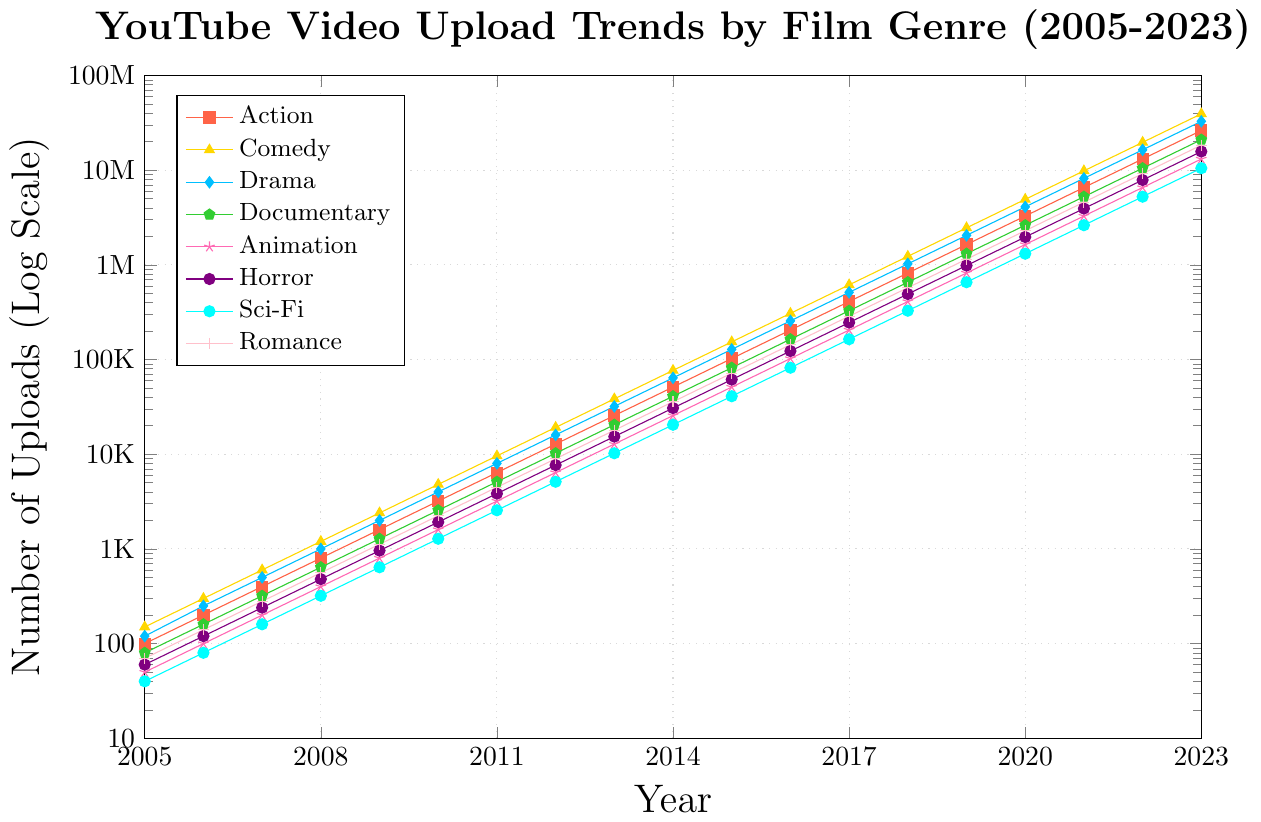What is the trend for the number of Comedy videos uploaded from 2005 to 2023? To identify the trend, observe the trajectory of the Comedy line on the chart. It starts low in 2005 and increases rapidly each year. Notice that the upload counts consistently rise, reflecting a significant growth trend throughout the period.
Answer: Increasing Which genre had fewer uploads in 2010, Animation or Horror? Locate the points for Animation and Horror in 2010. Compare the two values: Animation at approximately 1600 and Horror at roughly 1920. Since 1600 is less than 1920, Animation had fewer uploads.
Answer: Animation By how much did the number of Sci-Fi uploads increase from 2008 to 2012? Find the uploads for Sci-Fi in 2008 (320) and in 2012 (5120). Subtract the 2008 value from the 2012 value: 5120 - 320 = 4800. This indicates an increase of 4800 uploads between 2008 and 2012.
Answer: 4800 In which year did the number of Drama uploads first exceed 1 million? Look along the Drama line to identify when it crosses the 1 million mark. This occurs in 2018, where the y-axis value jumps to 1,024,000, confirming that 2018 is the first year it exceeds 1 million uploads.
Answer: 2018 Compare the growth rates of Action and Documentary genres from 2015 to 2020. Which one grew faster? For Action: From 1,024,000 in 2015 to 3,276,800 in 2020. Calculate the growth (3,276,800 - 1,024,000) / 1,024,000 ≈ 2.20 times. For Documentary: From 81,920 in 2015 to 2,621,440 in 2020. Calculate the growth (2,621,440 - 81,920) / 81,920 ≈ 31 times. Since 31 > 2.20, Documentary grew faster.
Answer: Documentary How many more uploads of Comedy videos were there than Documentary videos in 2023? Find the values for Comedy (39,321,600) and Documentary (20,971,520) in 2023. Subtract Documentary from Comedy: 39,321,600 - 20,971,520 = 18,350,080.
Answer: 18,350,080 What can be inferred about the popularity of Horror videos over time based on the chart? Observe the line representing Horror. It shows a significant upward trend, starting from 60 in 2005 and reaching 15,728,640 in 2023. This indicates a substantial increase in popularity over time.
Answer: Increased popularity Identify the genre with the least number of uploads in 2005 and provide the number. Locate the minimum value in 2005. Sci-Fi has the lowest number with 40 uploads.
Answer: Sci-Fi: 40 Which year saw a significant rise in the number of uploads across almost all genres? Examine years where all genres show a noticeable rise. In 2014, there is a clear increase in uploads across all genres compared to previous years, making 2014 stand out.
Answer: 2014 